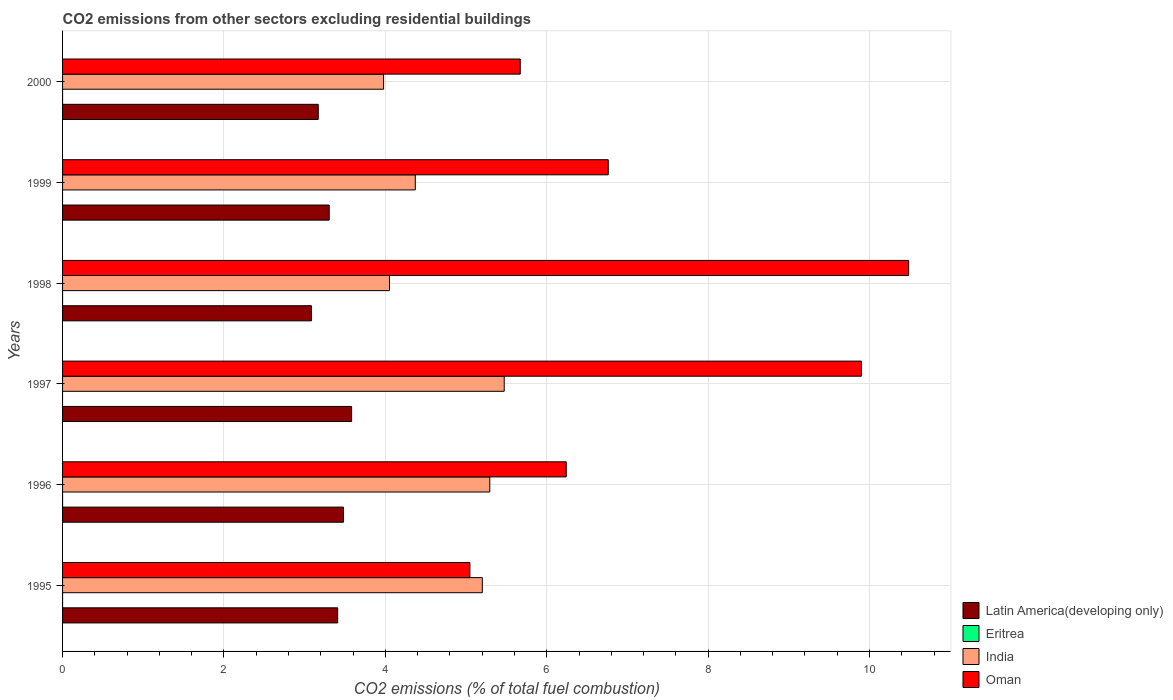How many different coloured bars are there?
Offer a terse response. 4. How many bars are there on the 1st tick from the top?
Give a very brief answer. 3. How many bars are there on the 6th tick from the bottom?
Offer a terse response. 3. In how many cases, is the number of bars for a given year not equal to the number of legend labels?
Offer a very short reply. 4. Across all years, what is the maximum total CO2 emitted in Latin America(developing only)?
Keep it short and to the point. 3.58. In which year was the total CO2 emitted in India maximum?
Provide a succinct answer. 1997. What is the total total CO2 emitted in Oman in the graph?
Give a very brief answer. 44.11. What is the difference between the total CO2 emitted in India in 1997 and that in 2000?
Ensure brevity in your answer.  1.49. What is the difference between the total CO2 emitted in Eritrea in 1996 and the total CO2 emitted in India in 2000?
Your answer should be very brief. -3.98. What is the average total CO2 emitted in India per year?
Provide a short and direct response. 4.73. In the year 1996, what is the difference between the total CO2 emitted in Latin America(developing only) and total CO2 emitted in India?
Your answer should be very brief. -1.81. What is the ratio of the total CO2 emitted in Latin America(developing only) in 1998 to that in 1999?
Provide a succinct answer. 0.93. Is the total CO2 emitted in India in 1997 less than that in 1999?
Offer a very short reply. No. Is the difference between the total CO2 emitted in Latin America(developing only) in 1998 and 1999 greater than the difference between the total CO2 emitted in India in 1998 and 1999?
Keep it short and to the point. Yes. What is the difference between the highest and the second highest total CO2 emitted in Oman?
Ensure brevity in your answer.  0.59. What is the difference between the highest and the lowest total CO2 emitted in Oman?
Keep it short and to the point. 5.44. How many bars are there?
Ensure brevity in your answer.  20. What is the difference between two consecutive major ticks on the X-axis?
Provide a short and direct response. 2. Are the values on the major ticks of X-axis written in scientific E-notation?
Your answer should be compact. No. Does the graph contain any zero values?
Make the answer very short. Yes. Where does the legend appear in the graph?
Offer a terse response. Bottom right. How many legend labels are there?
Provide a short and direct response. 4. What is the title of the graph?
Your answer should be compact. CO2 emissions from other sectors excluding residential buildings. Does "Pacific island small states" appear as one of the legend labels in the graph?
Offer a terse response. No. What is the label or title of the X-axis?
Offer a terse response. CO2 emissions (% of total fuel combustion). What is the CO2 emissions (% of total fuel combustion) in Latin America(developing only) in 1995?
Offer a terse response. 3.41. What is the CO2 emissions (% of total fuel combustion) of Eritrea in 1995?
Provide a succinct answer. 4.50577526227742e-16. What is the CO2 emissions (% of total fuel combustion) in India in 1995?
Your answer should be very brief. 5.2. What is the CO2 emissions (% of total fuel combustion) in Oman in 1995?
Your response must be concise. 5.05. What is the CO2 emissions (% of total fuel combustion) in Latin America(developing only) in 1996?
Make the answer very short. 3.48. What is the CO2 emissions (% of total fuel combustion) in India in 1996?
Offer a terse response. 5.29. What is the CO2 emissions (% of total fuel combustion) in Oman in 1996?
Keep it short and to the point. 6.24. What is the CO2 emissions (% of total fuel combustion) of Latin America(developing only) in 1997?
Provide a succinct answer. 3.58. What is the CO2 emissions (% of total fuel combustion) of Eritrea in 1997?
Your answer should be very brief. 0. What is the CO2 emissions (% of total fuel combustion) of India in 1997?
Offer a very short reply. 5.47. What is the CO2 emissions (% of total fuel combustion) in Oman in 1997?
Your response must be concise. 9.9. What is the CO2 emissions (% of total fuel combustion) of Latin America(developing only) in 1998?
Your response must be concise. 3.09. What is the CO2 emissions (% of total fuel combustion) in Eritrea in 1998?
Give a very brief answer. 5.88041856263324e-16. What is the CO2 emissions (% of total fuel combustion) of India in 1998?
Provide a short and direct response. 4.05. What is the CO2 emissions (% of total fuel combustion) of Oman in 1998?
Your answer should be compact. 10.48. What is the CO2 emissions (% of total fuel combustion) of Latin America(developing only) in 1999?
Provide a short and direct response. 3.3. What is the CO2 emissions (% of total fuel combustion) in Eritrea in 1999?
Provide a succinct answer. 0. What is the CO2 emissions (% of total fuel combustion) of India in 1999?
Provide a succinct answer. 4.37. What is the CO2 emissions (% of total fuel combustion) in Oman in 1999?
Your response must be concise. 6.76. What is the CO2 emissions (% of total fuel combustion) in Latin America(developing only) in 2000?
Ensure brevity in your answer.  3.17. What is the CO2 emissions (% of total fuel combustion) in India in 2000?
Your answer should be very brief. 3.98. What is the CO2 emissions (% of total fuel combustion) of Oman in 2000?
Provide a succinct answer. 5.67. Across all years, what is the maximum CO2 emissions (% of total fuel combustion) of Latin America(developing only)?
Provide a succinct answer. 3.58. Across all years, what is the maximum CO2 emissions (% of total fuel combustion) in Eritrea?
Make the answer very short. 5.88041856263324e-16. Across all years, what is the maximum CO2 emissions (% of total fuel combustion) in India?
Your answer should be very brief. 5.47. Across all years, what is the maximum CO2 emissions (% of total fuel combustion) of Oman?
Your answer should be very brief. 10.48. Across all years, what is the minimum CO2 emissions (% of total fuel combustion) of Latin America(developing only)?
Provide a succinct answer. 3.09. Across all years, what is the minimum CO2 emissions (% of total fuel combustion) of Eritrea?
Make the answer very short. 0. Across all years, what is the minimum CO2 emissions (% of total fuel combustion) of India?
Your response must be concise. 3.98. Across all years, what is the minimum CO2 emissions (% of total fuel combustion) of Oman?
Your answer should be very brief. 5.05. What is the total CO2 emissions (% of total fuel combustion) in Latin America(developing only) in the graph?
Give a very brief answer. 20.03. What is the total CO2 emissions (% of total fuel combustion) in Eritrea in the graph?
Your response must be concise. 0. What is the total CO2 emissions (% of total fuel combustion) of India in the graph?
Keep it short and to the point. 28.37. What is the total CO2 emissions (% of total fuel combustion) of Oman in the graph?
Ensure brevity in your answer.  44.11. What is the difference between the CO2 emissions (% of total fuel combustion) of Latin America(developing only) in 1995 and that in 1996?
Your answer should be very brief. -0.07. What is the difference between the CO2 emissions (% of total fuel combustion) of India in 1995 and that in 1996?
Offer a terse response. -0.09. What is the difference between the CO2 emissions (% of total fuel combustion) of Oman in 1995 and that in 1996?
Your answer should be compact. -1.19. What is the difference between the CO2 emissions (% of total fuel combustion) of Latin America(developing only) in 1995 and that in 1997?
Keep it short and to the point. -0.17. What is the difference between the CO2 emissions (% of total fuel combustion) in India in 1995 and that in 1997?
Ensure brevity in your answer.  -0.27. What is the difference between the CO2 emissions (% of total fuel combustion) of Oman in 1995 and that in 1997?
Offer a terse response. -4.85. What is the difference between the CO2 emissions (% of total fuel combustion) of Latin America(developing only) in 1995 and that in 1998?
Keep it short and to the point. 0.32. What is the difference between the CO2 emissions (% of total fuel combustion) in Eritrea in 1995 and that in 1998?
Offer a terse response. -0. What is the difference between the CO2 emissions (% of total fuel combustion) of India in 1995 and that in 1998?
Provide a succinct answer. 1.15. What is the difference between the CO2 emissions (% of total fuel combustion) of Oman in 1995 and that in 1998?
Make the answer very short. -5.44. What is the difference between the CO2 emissions (% of total fuel combustion) of Latin America(developing only) in 1995 and that in 1999?
Your answer should be compact. 0.1. What is the difference between the CO2 emissions (% of total fuel combustion) of India in 1995 and that in 1999?
Your answer should be very brief. 0.83. What is the difference between the CO2 emissions (% of total fuel combustion) of Oman in 1995 and that in 1999?
Offer a very short reply. -1.71. What is the difference between the CO2 emissions (% of total fuel combustion) of Latin America(developing only) in 1995 and that in 2000?
Keep it short and to the point. 0.24. What is the difference between the CO2 emissions (% of total fuel combustion) in India in 1995 and that in 2000?
Your answer should be very brief. 1.22. What is the difference between the CO2 emissions (% of total fuel combustion) in Oman in 1995 and that in 2000?
Your response must be concise. -0.62. What is the difference between the CO2 emissions (% of total fuel combustion) of Latin America(developing only) in 1996 and that in 1997?
Offer a terse response. -0.1. What is the difference between the CO2 emissions (% of total fuel combustion) of India in 1996 and that in 1997?
Your response must be concise. -0.18. What is the difference between the CO2 emissions (% of total fuel combustion) in Oman in 1996 and that in 1997?
Keep it short and to the point. -3.66. What is the difference between the CO2 emissions (% of total fuel combustion) in Latin America(developing only) in 1996 and that in 1998?
Your answer should be compact. 0.4. What is the difference between the CO2 emissions (% of total fuel combustion) in India in 1996 and that in 1998?
Give a very brief answer. 1.24. What is the difference between the CO2 emissions (% of total fuel combustion) in Oman in 1996 and that in 1998?
Ensure brevity in your answer.  -4.24. What is the difference between the CO2 emissions (% of total fuel combustion) in Latin America(developing only) in 1996 and that in 1999?
Provide a short and direct response. 0.18. What is the difference between the CO2 emissions (% of total fuel combustion) in India in 1996 and that in 1999?
Offer a very short reply. 0.92. What is the difference between the CO2 emissions (% of total fuel combustion) in Oman in 1996 and that in 1999?
Offer a terse response. -0.52. What is the difference between the CO2 emissions (% of total fuel combustion) of Latin America(developing only) in 1996 and that in 2000?
Your response must be concise. 0.31. What is the difference between the CO2 emissions (% of total fuel combustion) in India in 1996 and that in 2000?
Keep it short and to the point. 1.32. What is the difference between the CO2 emissions (% of total fuel combustion) in Oman in 1996 and that in 2000?
Ensure brevity in your answer.  0.57. What is the difference between the CO2 emissions (% of total fuel combustion) of Latin America(developing only) in 1997 and that in 1998?
Provide a short and direct response. 0.5. What is the difference between the CO2 emissions (% of total fuel combustion) in India in 1997 and that in 1998?
Make the answer very short. 1.42. What is the difference between the CO2 emissions (% of total fuel combustion) of Oman in 1997 and that in 1998?
Make the answer very short. -0.59. What is the difference between the CO2 emissions (% of total fuel combustion) of Latin America(developing only) in 1997 and that in 1999?
Offer a very short reply. 0.28. What is the difference between the CO2 emissions (% of total fuel combustion) of India in 1997 and that in 1999?
Provide a short and direct response. 1.1. What is the difference between the CO2 emissions (% of total fuel combustion) in Oman in 1997 and that in 1999?
Offer a terse response. 3.14. What is the difference between the CO2 emissions (% of total fuel combustion) of Latin America(developing only) in 1997 and that in 2000?
Provide a succinct answer. 0.41. What is the difference between the CO2 emissions (% of total fuel combustion) in India in 1997 and that in 2000?
Ensure brevity in your answer.  1.49. What is the difference between the CO2 emissions (% of total fuel combustion) in Oman in 1997 and that in 2000?
Give a very brief answer. 4.23. What is the difference between the CO2 emissions (% of total fuel combustion) in Latin America(developing only) in 1998 and that in 1999?
Keep it short and to the point. -0.22. What is the difference between the CO2 emissions (% of total fuel combustion) of India in 1998 and that in 1999?
Offer a very short reply. -0.32. What is the difference between the CO2 emissions (% of total fuel combustion) of Oman in 1998 and that in 1999?
Offer a very short reply. 3.72. What is the difference between the CO2 emissions (% of total fuel combustion) of Latin America(developing only) in 1998 and that in 2000?
Your response must be concise. -0.08. What is the difference between the CO2 emissions (% of total fuel combustion) in India in 1998 and that in 2000?
Your answer should be compact. 0.07. What is the difference between the CO2 emissions (% of total fuel combustion) of Oman in 1998 and that in 2000?
Offer a terse response. 4.81. What is the difference between the CO2 emissions (% of total fuel combustion) in Latin America(developing only) in 1999 and that in 2000?
Ensure brevity in your answer.  0.14. What is the difference between the CO2 emissions (% of total fuel combustion) of India in 1999 and that in 2000?
Make the answer very short. 0.39. What is the difference between the CO2 emissions (% of total fuel combustion) of Oman in 1999 and that in 2000?
Provide a short and direct response. 1.09. What is the difference between the CO2 emissions (% of total fuel combustion) in Latin America(developing only) in 1995 and the CO2 emissions (% of total fuel combustion) in India in 1996?
Your answer should be very brief. -1.88. What is the difference between the CO2 emissions (% of total fuel combustion) in Latin America(developing only) in 1995 and the CO2 emissions (% of total fuel combustion) in Oman in 1996?
Your answer should be very brief. -2.83. What is the difference between the CO2 emissions (% of total fuel combustion) in Eritrea in 1995 and the CO2 emissions (% of total fuel combustion) in India in 1996?
Ensure brevity in your answer.  -5.29. What is the difference between the CO2 emissions (% of total fuel combustion) of Eritrea in 1995 and the CO2 emissions (% of total fuel combustion) of Oman in 1996?
Offer a terse response. -6.24. What is the difference between the CO2 emissions (% of total fuel combustion) of India in 1995 and the CO2 emissions (% of total fuel combustion) of Oman in 1996?
Make the answer very short. -1.04. What is the difference between the CO2 emissions (% of total fuel combustion) of Latin America(developing only) in 1995 and the CO2 emissions (% of total fuel combustion) of India in 1997?
Offer a terse response. -2.06. What is the difference between the CO2 emissions (% of total fuel combustion) in Latin America(developing only) in 1995 and the CO2 emissions (% of total fuel combustion) in Oman in 1997?
Your response must be concise. -6.49. What is the difference between the CO2 emissions (% of total fuel combustion) of Eritrea in 1995 and the CO2 emissions (% of total fuel combustion) of India in 1997?
Provide a succinct answer. -5.47. What is the difference between the CO2 emissions (% of total fuel combustion) of Eritrea in 1995 and the CO2 emissions (% of total fuel combustion) of Oman in 1997?
Offer a very short reply. -9.9. What is the difference between the CO2 emissions (% of total fuel combustion) in India in 1995 and the CO2 emissions (% of total fuel combustion) in Oman in 1997?
Give a very brief answer. -4.7. What is the difference between the CO2 emissions (% of total fuel combustion) of Latin America(developing only) in 1995 and the CO2 emissions (% of total fuel combustion) of Eritrea in 1998?
Offer a very short reply. 3.41. What is the difference between the CO2 emissions (% of total fuel combustion) of Latin America(developing only) in 1995 and the CO2 emissions (% of total fuel combustion) of India in 1998?
Make the answer very short. -0.64. What is the difference between the CO2 emissions (% of total fuel combustion) in Latin America(developing only) in 1995 and the CO2 emissions (% of total fuel combustion) in Oman in 1998?
Offer a terse response. -7.08. What is the difference between the CO2 emissions (% of total fuel combustion) in Eritrea in 1995 and the CO2 emissions (% of total fuel combustion) in India in 1998?
Keep it short and to the point. -4.05. What is the difference between the CO2 emissions (% of total fuel combustion) in Eritrea in 1995 and the CO2 emissions (% of total fuel combustion) in Oman in 1998?
Your response must be concise. -10.48. What is the difference between the CO2 emissions (% of total fuel combustion) in India in 1995 and the CO2 emissions (% of total fuel combustion) in Oman in 1998?
Provide a short and direct response. -5.28. What is the difference between the CO2 emissions (% of total fuel combustion) in Latin America(developing only) in 1995 and the CO2 emissions (% of total fuel combustion) in India in 1999?
Ensure brevity in your answer.  -0.96. What is the difference between the CO2 emissions (% of total fuel combustion) of Latin America(developing only) in 1995 and the CO2 emissions (% of total fuel combustion) of Oman in 1999?
Offer a terse response. -3.35. What is the difference between the CO2 emissions (% of total fuel combustion) of Eritrea in 1995 and the CO2 emissions (% of total fuel combustion) of India in 1999?
Your answer should be compact. -4.37. What is the difference between the CO2 emissions (% of total fuel combustion) of Eritrea in 1995 and the CO2 emissions (% of total fuel combustion) of Oman in 1999?
Offer a terse response. -6.76. What is the difference between the CO2 emissions (% of total fuel combustion) of India in 1995 and the CO2 emissions (% of total fuel combustion) of Oman in 1999?
Provide a succinct answer. -1.56. What is the difference between the CO2 emissions (% of total fuel combustion) in Latin America(developing only) in 1995 and the CO2 emissions (% of total fuel combustion) in India in 2000?
Make the answer very short. -0.57. What is the difference between the CO2 emissions (% of total fuel combustion) in Latin America(developing only) in 1995 and the CO2 emissions (% of total fuel combustion) in Oman in 2000?
Keep it short and to the point. -2.26. What is the difference between the CO2 emissions (% of total fuel combustion) of Eritrea in 1995 and the CO2 emissions (% of total fuel combustion) of India in 2000?
Provide a short and direct response. -3.98. What is the difference between the CO2 emissions (% of total fuel combustion) in Eritrea in 1995 and the CO2 emissions (% of total fuel combustion) in Oman in 2000?
Give a very brief answer. -5.67. What is the difference between the CO2 emissions (% of total fuel combustion) in India in 1995 and the CO2 emissions (% of total fuel combustion) in Oman in 2000?
Your answer should be very brief. -0.47. What is the difference between the CO2 emissions (% of total fuel combustion) in Latin America(developing only) in 1996 and the CO2 emissions (% of total fuel combustion) in India in 1997?
Your answer should be very brief. -1.99. What is the difference between the CO2 emissions (% of total fuel combustion) in Latin America(developing only) in 1996 and the CO2 emissions (% of total fuel combustion) in Oman in 1997?
Offer a terse response. -6.42. What is the difference between the CO2 emissions (% of total fuel combustion) of India in 1996 and the CO2 emissions (% of total fuel combustion) of Oman in 1997?
Your answer should be compact. -4.61. What is the difference between the CO2 emissions (% of total fuel combustion) in Latin America(developing only) in 1996 and the CO2 emissions (% of total fuel combustion) in Eritrea in 1998?
Your answer should be very brief. 3.48. What is the difference between the CO2 emissions (% of total fuel combustion) in Latin America(developing only) in 1996 and the CO2 emissions (% of total fuel combustion) in India in 1998?
Provide a succinct answer. -0.57. What is the difference between the CO2 emissions (% of total fuel combustion) of Latin America(developing only) in 1996 and the CO2 emissions (% of total fuel combustion) of Oman in 1998?
Your answer should be compact. -7. What is the difference between the CO2 emissions (% of total fuel combustion) in India in 1996 and the CO2 emissions (% of total fuel combustion) in Oman in 1998?
Offer a terse response. -5.19. What is the difference between the CO2 emissions (% of total fuel combustion) in Latin America(developing only) in 1996 and the CO2 emissions (% of total fuel combustion) in India in 1999?
Your answer should be compact. -0.89. What is the difference between the CO2 emissions (% of total fuel combustion) of Latin America(developing only) in 1996 and the CO2 emissions (% of total fuel combustion) of Oman in 1999?
Ensure brevity in your answer.  -3.28. What is the difference between the CO2 emissions (% of total fuel combustion) of India in 1996 and the CO2 emissions (% of total fuel combustion) of Oman in 1999?
Provide a short and direct response. -1.47. What is the difference between the CO2 emissions (% of total fuel combustion) in Latin America(developing only) in 1996 and the CO2 emissions (% of total fuel combustion) in India in 2000?
Ensure brevity in your answer.  -0.5. What is the difference between the CO2 emissions (% of total fuel combustion) of Latin America(developing only) in 1996 and the CO2 emissions (% of total fuel combustion) of Oman in 2000?
Provide a succinct answer. -2.19. What is the difference between the CO2 emissions (% of total fuel combustion) in India in 1996 and the CO2 emissions (% of total fuel combustion) in Oman in 2000?
Offer a terse response. -0.38. What is the difference between the CO2 emissions (% of total fuel combustion) in Latin America(developing only) in 1997 and the CO2 emissions (% of total fuel combustion) in Eritrea in 1998?
Your answer should be compact. 3.58. What is the difference between the CO2 emissions (% of total fuel combustion) of Latin America(developing only) in 1997 and the CO2 emissions (% of total fuel combustion) of India in 1998?
Offer a very short reply. -0.47. What is the difference between the CO2 emissions (% of total fuel combustion) in Latin America(developing only) in 1997 and the CO2 emissions (% of total fuel combustion) in Oman in 1998?
Offer a very short reply. -6.9. What is the difference between the CO2 emissions (% of total fuel combustion) in India in 1997 and the CO2 emissions (% of total fuel combustion) in Oman in 1998?
Keep it short and to the point. -5.01. What is the difference between the CO2 emissions (% of total fuel combustion) in Latin America(developing only) in 1997 and the CO2 emissions (% of total fuel combustion) in India in 1999?
Provide a short and direct response. -0.79. What is the difference between the CO2 emissions (% of total fuel combustion) of Latin America(developing only) in 1997 and the CO2 emissions (% of total fuel combustion) of Oman in 1999?
Your response must be concise. -3.18. What is the difference between the CO2 emissions (% of total fuel combustion) of India in 1997 and the CO2 emissions (% of total fuel combustion) of Oman in 1999?
Provide a succinct answer. -1.29. What is the difference between the CO2 emissions (% of total fuel combustion) in Latin America(developing only) in 1997 and the CO2 emissions (% of total fuel combustion) in India in 2000?
Offer a very short reply. -0.4. What is the difference between the CO2 emissions (% of total fuel combustion) of Latin America(developing only) in 1997 and the CO2 emissions (% of total fuel combustion) of Oman in 2000?
Make the answer very short. -2.09. What is the difference between the CO2 emissions (% of total fuel combustion) in India in 1997 and the CO2 emissions (% of total fuel combustion) in Oman in 2000?
Make the answer very short. -0.2. What is the difference between the CO2 emissions (% of total fuel combustion) in Latin America(developing only) in 1998 and the CO2 emissions (% of total fuel combustion) in India in 1999?
Offer a terse response. -1.29. What is the difference between the CO2 emissions (% of total fuel combustion) of Latin America(developing only) in 1998 and the CO2 emissions (% of total fuel combustion) of Oman in 1999?
Make the answer very short. -3.68. What is the difference between the CO2 emissions (% of total fuel combustion) in Eritrea in 1998 and the CO2 emissions (% of total fuel combustion) in India in 1999?
Give a very brief answer. -4.37. What is the difference between the CO2 emissions (% of total fuel combustion) of Eritrea in 1998 and the CO2 emissions (% of total fuel combustion) of Oman in 1999?
Offer a terse response. -6.76. What is the difference between the CO2 emissions (% of total fuel combustion) in India in 1998 and the CO2 emissions (% of total fuel combustion) in Oman in 1999?
Give a very brief answer. -2.71. What is the difference between the CO2 emissions (% of total fuel combustion) in Latin America(developing only) in 1998 and the CO2 emissions (% of total fuel combustion) in India in 2000?
Give a very brief answer. -0.89. What is the difference between the CO2 emissions (% of total fuel combustion) in Latin America(developing only) in 1998 and the CO2 emissions (% of total fuel combustion) in Oman in 2000?
Provide a succinct answer. -2.59. What is the difference between the CO2 emissions (% of total fuel combustion) in Eritrea in 1998 and the CO2 emissions (% of total fuel combustion) in India in 2000?
Your response must be concise. -3.98. What is the difference between the CO2 emissions (% of total fuel combustion) of Eritrea in 1998 and the CO2 emissions (% of total fuel combustion) of Oman in 2000?
Your response must be concise. -5.67. What is the difference between the CO2 emissions (% of total fuel combustion) of India in 1998 and the CO2 emissions (% of total fuel combustion) of Oman in 2000?
Your answer should be very brief. -1.62. What is the difference between the CO2 emissions (% of total fuel combustion) of Latin America(developing only) in 1999 and the CO2 emissions (% of total fuel combustion) of India in 2000?
Offer a very short reply. -0.67. What is the difference between the CO2 emissions (% of total fuel combustion) of Latin America(developing only) in 1999 and the CO2 emissions (% of total fuel combustion) of Oman in 2000?
Offer a terse response. -2.37. What is the difference between the CO2 emissions (% of total fuel combustion) of India in 1999 and the CO2 emissions (% of total fuel combustion) of Oman in 2000?
Keep it short and to the point. -1.3. What is the average CO2 emissions (% of total fuel combustion) of Latin America(developing only) per year?
Ensure brevity in your answer.  3.34. What is the average CO2 emissions (% of total fuel combustion) of India per year?
Offer a very short reply. 4.73. What is the average CO2 emissions (% of total fuel combustion) of Oman per year?
Keep it short and to the point. 7.35. In the year 1995, what is the difference between the CO2 emissions (% of total fuel combustion) of Latin America(developing only) and CO2 emissions (% of total fuel combustion) of Eritrea?
Your answer should be very brief. 3.41. In the year 1995, what is the difference between the CO2 emissions (% of total fuel combustion) in Latin America(developing only) and CO2 emissions (% of total fuel combustion) in India?
Your response must be concise. -1.79. In the year 1995, what is the difference between the CO2 emissions (% of total fuel combustion) of Latin America(developing only) and CO2 emissions (% of total fuel combustion) of Oman?
Your answer should be very brief. -1.64. In the year 1995, what is the difference between the CO2 emissions (% of total fuel combustion) of Eritrea and CO2 emissions (% of total fuel combustion) of India?
Your answer should be very brief. -5.2. In the year 1995, what is the difference between the CO2 emissions (% of total fuel combustion) of Eritrea and CO2 emissions (% of total fuel combustion) of Oman?
Offer a terse response. -5.05. In the year 1995, what is the difference between the CO2 emissions (% of total fuel combustion) in India and CO2 emissions (% of total fuel combustion) in Oman?
Ensure brevity in your answer.  0.15. In the year 1996, what is the difference between the CO2 emissions (% of total fuel combustion) of Latin America(developing only) and CO2 emissions (% of total fuel combustion) of India?
Offer a terse response. -1.81. In the year 1996, what is the difference between the CO2 emissions (% of total fuel combustion) in Latin America(developing only) and CO2 emissions (% of total fuel combustion) in Oman?
Provide a succinct answer. -2.76. In the year 1996, what is the difference between the CO2 emissions (% of total fuel combustion) in India and CO2 emissions (% of total fuel combustion) in Oman?
Your answer should be compact. -0.95. In the year 1997, what is the difference between the CO2 emissions (% of total fuel combustion) of Latin America(developing only) and CO2 emissions (% of total fuel combustion) of India?
Provide a succinct answer. -1.89. In the year 1997, what is the difference between the CO2 emissions (% of total fuel combustion) in Latin America(developing only) and CO2 emissions (% of total fuel combustion) in Oman?
Your response must be concise. -6.32. In the year 1997, what is the difference between the CO2 emissions (% of total fuel combustion) of India and CO2 emissions (% of total fuel combustion) of Oman?
Make the answer very short. -4.43. In the year 1998, what is the difference between the CO2 emissions (% of total fuel combustion) in Latin America(developing only) and CO2 emissions (% of total fuel combustion) in Eritrea?
Offer a very short reply. 3.09. In the year 1998, what is the difference between the CO2 emissions (% of total fuel combustion) in Latin America(developing only) and CO2 emissions (% of total fuel combustion) in India?
Ensure brevity in your answer.  -0.97. In the year 1998, what is the difference between the CO2 emissions (% of total fuel combustion) in Latin America(developing only) and CO2 emissions (% of total fuel combustion) in Oman?
Provide a short and direct response. -7.4. In the year 1998, what is the difference between the CO2 emissions (% of total fuel combustion) in Eritrea and CO2 emissions (% of total fuel combustion) in India?
Make the answer very short. -4.05. In the year 1998, what is the difference between the CO2 emissions (% of total fuel combustion) of Eritrea and CO2 emissions (% of total fuel combustion) of Oman?
Ensure brevity in your answer.  -10.48. In the year 1998, what is the difference between the CO2 emissions (% of total fuel combustion) of India and CO2 emissions (% of total fuel combustion) of Oman?
Offer a terse response. -6.43. In the year 1999, what is the difference between the CO2 emissions (% of total fuel combustion) of Latin America(developing only) and CO2 emissions (% of total fuel combustion) of India?
Ensure brevity in your answer.  -1.07. In the year 1999, what is the difference between the CO2 emissions (% of total fuel combustion) of Latin America(developing only) and CO2 emissions (% of total fuel combustion) of Oman?
Your answer should be very brief. -3.46. In the year 1999, what is the difference between the CO2 emissions (% of total fuel combustion) in India and CO2 emissions (% of total fuel combustion) in Oman?
Your answer should be compact. -2.39. In the year 2000, what is the difference between the CO2 emissions (% of total fuel combustion) in Latin America(developing only) and CO2 emissions (% of total fuel combustion) in India?
Your response must be concise. -0.81. In the year 2000, what is the difference between the CO2 emissions (% of total fuel combustion) of Latin America(developing only) and CO2 emissions (% of total fuel combustion) of Oman?
Provide a succinct answer. -2.5. In the year 2000, what is the difference between the CO2 emissions (% of total fuel combustion) in India and CO2 emissions (% of total fuel combustion) in Oman?
Offer a very short reply. -1.69. What is the ratio of the CO2 emissions (% of total fuel combustion) in Latin America(developing only) in 1995 to that in 1996?
Provide a short and direct response. 0.98. What is the ratio of the CO2 emissions (% of total fuel combustion) of India in 1995 to that in 1996?
Offer a terse response. 0.98. What is the ratio of the CO2 emissions (% of total fuel combustion) of Oman in 1995 to that in 1996?
Your answer should be very brief. 0.81. What is the ratio of the CO2 emissions (% of total fuel combustion) in Latin America(developing only) in 1995 to that in 1997?
Give a very brief answer. 0.95. What is the ratio of the CO2 emissions (% of total fuel combustion) of India in 1995 to that in 1997?
Offer a very short reply. 0.95. What is the ratio of the CO2 emissions (% of total fuel combustion) of Oman in 1995 to that in 1997?
Give a very brief answer. 0.51. What is the ratio of the CO2 emissions (% of total fuel combustion) in Latin America(developing only) in 1995 to that in 1998?
Make the answer very short. 1.11. What is the ratio of the CO2 emissions (% of total fuel combustion) of Eritrea in 1995 to that in 1998?
Provide a succinct answer. 0.77. What is the ratio of the CO2 emissions (% of total fuel combustion) in India in 1995 to that in 1998?
Offer a terse response. 1.28. What is the ratio of the CO2 emissions (% of total fuel combustion) in Oman in 1995 to that in 1998?
Offer a terse response. 0.48. What is the ratio of the CO2 emissions (% of total fuel combustion) of Latin America(developing only) in 1995 to that in 1999?
Offer a terse response. 1.03. What is the ratio of the CO2 emissions (% of total fuel combustion) in India in 1995 to that in 1999?
Keep it short and to the point. 1.19. What is the ratio of the CO2 emissions (% of total fuel combustion) in Oman in 1995 to that in 1999?
Offer a very short reply. 0.75. What is the ratio of the CO2 emissions (% of total fuel combustion) of Latin America(developing only) in 1995 to that in 2000?
Provide a succinct answer. 1.08. What is the ratio of the CO2 emissions (% of total fuel combustion) in India in 1995 to that in 2000?
Provide a succinct answer. 1.31. What is the ratio of the CO2 emissions (% of total fuel combustion) of Oman in 1995 to that in 2000?
Give a very brief answer. 0.89. What is the ratio of the CO2 emissions (% of total fuel combustion) in Latin America(developing only) in 1996 to that in 1997?
Provide a succinct answer. 0.97. What is the ratio of the CO2 emissions (% of total fuel combustion) of India in 1996 to that in 1997?
Your answer should be very brief. 0.97. What is the ratio of the CO2 emissions (% of total fuel combustion) in Oman in 1996 to that in 1997?
Provide a short and direct response. 0.63. What is the ratio of the CO2 emissions (% of total fuel combustion) of Latin America(developing only) in 1996 to that in 1998?
Provide a short and direct response. 1.13. What is the ratio of the CO2 emissions (% of total fuel combustion) in India in 1996 to that in 1998?
Provide a succinct answer. 1.31. What is the ratio of the CO2 emissions (% of total fuel combustion) of Oman in 1996 to that in 1998?
Provide a succinct answer. 0.6. What is the ratio of the CO2 emissions (% of total fuel combustion) in Latin America(developing only) in 1996 to that in 1999?
Provide a short and direct response. 1.05. What is the ratio of the CO2 emissions (% of total fuel combustion) of India in 1996 to that in 1999?
Ensure brevity in your answer.  1.21. What is the ratio of the CO2 emissions (% of total fuel combustion) of Oman in 1996 to that in 1999?
Make the answer very short. 0.92. What is the ratio of the CO2 emissions (% of total fuel combustion) in Latin America(developing only) in 1996 to that in 2000?
Ensure brevity in your answer.  1.1. What is the ratio of the CO2 emissions (% of total fuel combustion) in India in 1996 to that in 2000?
Your answer should be very brief. 1.33. What is the ratio of the CO2 emissions (% of total fuel combustion) in Oman in 1996 to that in 2000?
Provide a short and direct response. 1.1. What is the ratio of the CO2 emissions (% of total fuel combustion) in Latin America(developing only) in 1997 to that in 1998?
Make the answer very short. 1.16. What is the ratio of the CO2 emissions (% of total fuel combustion) of India in 1997 to that in 1998?
Provide a short and direct response. 1.35. What is the ratio of the CO2 emissions (% of total fuel combustion) in Oman in 1997 to that in 1998?
Give a very brief answer. 0.94. What is the ratio of the CO2 emissions (% of total fuel combustion) of Latin America(developing only) in 1997 to that in 1999?
Your answer should be compact. 1.08. What is the ratio of the CO2 emissions (% of total fuel combustion) of India in 1997 to that in 1999?
Your answer should be very brief. 1.25. What is the ratio of the CO2 emissions (% of total fuel combustion) of Oman in 1997 to that in 1999?
Keep it short and to the point. 1.46. What is the ratio of the CO2 emissions (% of total fuel combustion) of Latin America(developing only) in 1997 to that in 2000?
Provide a succinct answer. 1.13. What is the ratio of the CO2 emissions (% of total fuel combustion) of India in 1997 to that in 2000?
Ensure brevity in your answer.  1.38. What is the ratio of the CO2 emissions (% of total fuel combustion) in Oman in 1997 to that in 2000?
Provide a succinct answer. 1.75. What is the ratio of the CO2 emissions (% of total fuel combustion) of Latin America(developing only) in 1998 to that in 1999?
Keep it short and to the point. 0.93. What is the ratio of the CO2 emissions (% of total fuel combustion) in India in 1998 to that in 1999?
Your answer should be compact. 0.93. What is the ratio of the CO2 emissions (% of total fuel combustion) in Oman in 1998 to that in 1999?
Make the answer very short. 1.55. What is the ratio of the CO2 emissions (% of total fuel combustion) in Latin America(developing only) in 1998 to that in 2000?
Your answer should be very brief. 0.97. What is the ratio of the CO2 emissions (% of total fuel combustion) in India in 1998 to that in 2000?
Ensure brevity in your answer.  1.02. What is the ratio of the CO2 emissions (% of total fuel combustion) in Oman in 1998 to that in 2000?
Ensure brevity in your answer.  1.85. What is the ratio of the CO2 emissions (% of total fuel combustion) in Latin America(developing only) in 1999 to that in 2000?
Make the answer very short. 1.04. What is the ratio of the CO2 emissions (% of total fuel combustion) in India in 1999 to that in 2000?
Offer a very short reply. 1.1. What is the ratio of the CO2 emissions (% of total fuel combustion) of Oman in 1999 to that in 2000?
Your answer should be very brief. 1.19. What is the difference between the highest and the second highest CO2 emissions (% of total fuel combustion) in Latin America(developing only)?
Provide a short and direct response. 0.1. What is the difference between the highest and the second highest CO2 emissions (% of total fuel combustion) in India?
Make the answer very short. 0.18. What is the difference between the highest and the second highest CO2 emissions (% of total fuel combustion) in Oman?
Offer a very short reply. 0.59. What is the difference between the highest and the lowest CO2 emissions (% of total fuel combustion) of Latin America(developing only)?
Provide a succinct answer. 0.5. What is the difference between the highest and the lowest CO2 emissions (% of total fuel combustion) of Eritrea?
Your answer should be very brief. 0. What is the difference between the highest and the lowest CO2 emissions (% of total fuel combustion) of India?
Keep it short and to the point. 1.49. What is the difference between the highest and the lowest CO2 emissions (% of total fuel combustion) in Oman?
Give a very brief answer. 5.44. 